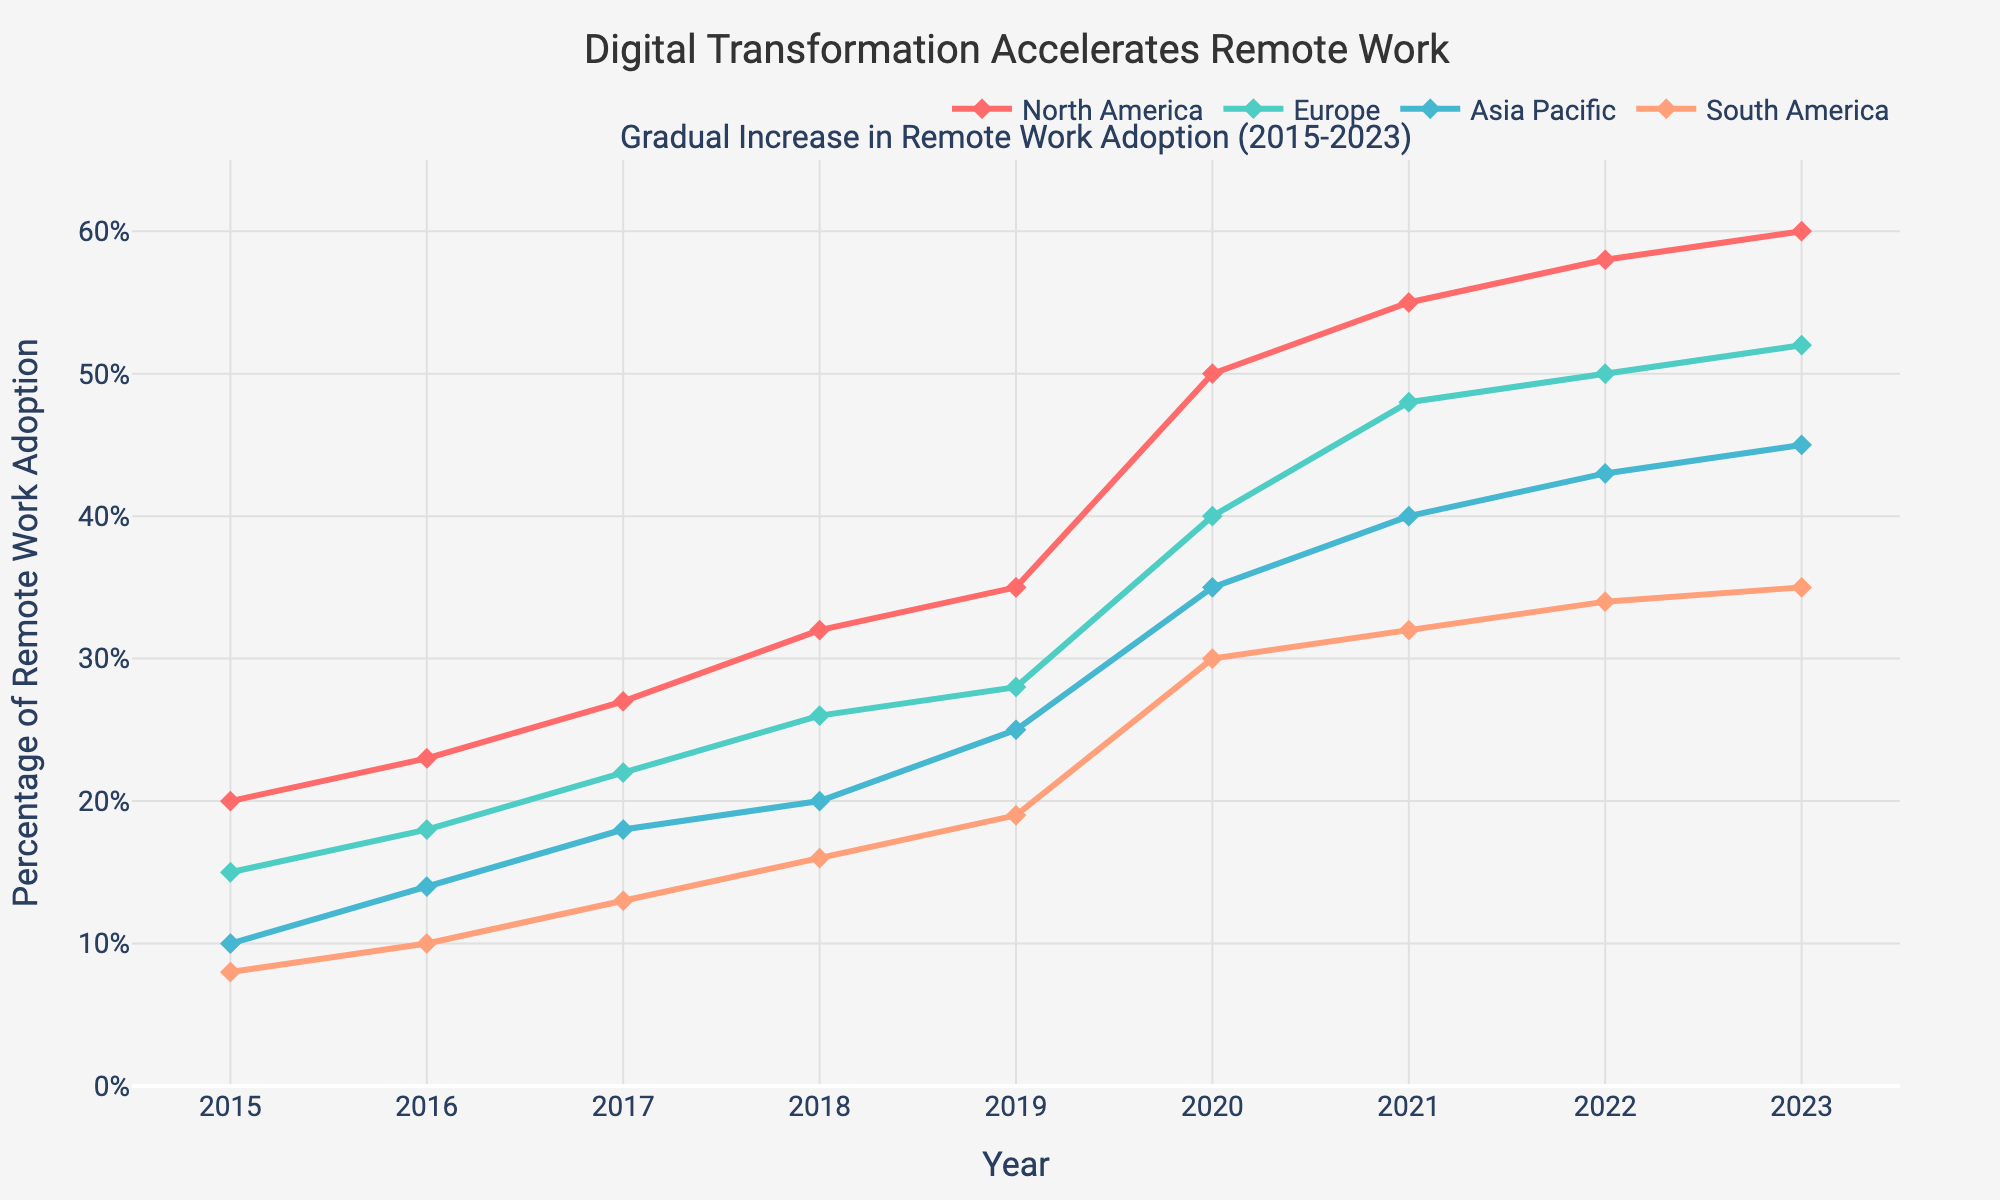What's the title of the figure? The title is located at the top of the figure and it reads "Gradual Increase in Remote Work Adoption (2015-2023)".
Answer: Gradual Increase in Remote Work Adoption (2015-2023) What is the percentage of remote work adoption in North America in 2020? Locate the line representing North America and find the data point for the year 2020. The percentage value at that point is 50%.
Answer: 50% Which region showed the highest percentage of remote work adoption in 2023? Review the end points of all lines on the plot for the year 2023. The line representing North America reaches the highest value at 60%.
Answer: North America On average, how much did the percentage increase per year in Europe from 2015 to 2023? Calculate the difference between the 2023 value (52%) and the 2015 value (15%) for Europe, then divide by the number of years (2023-2015 = 8 years). This gives an average annual increase of (52-15)/8 = 4.625%.
Answer: 4.625% Compare the percentage increase in remote work adoption from 2019 to 2020 in North America and Asia Pacific. Which region experienced a larger increase? For North America, the increase is from 35% in 2019 to 50% in 2020 (15% increase). For Asia Pacific, the increase is from 25% in 2019 to 35% in 2020 (10% increase). North America experienced a larger increase.
Answer: North America Which region had the smallest growth percentage from 2015 to 2023? Calculate the total increase for each region and compare them. North America (60-20=40), Europe (52-15=37), Asia Pacific (45-10=35), South America (35-8=27). The smallest increase is in South America at 27%.
Answer: South America Estimate the overall percentage increase in remote work adoption across all regions from 2015 to 2023. Sum the percentage increases for each region: North America (40), Europe (37), Asia Pacific (35), and South America (27). The total is 139%. The average increase per region is 139% / 4 = 34.75%.
Answer: 34.75% How does the percentage of remote work adoption in Europe compare to North America in 2022? Locate the values for Europe and North America in 2022 on the plot. Europe has 50%, while North America has 58%. Europe has 8% less adoption than North America.
Answer: 8% less From which year did North America see an accelerated increase in remote work adoption? Observe the slope of the line representing North America. A noticeable steep increase begins between 2019 and 2020.
Answer: 2020 